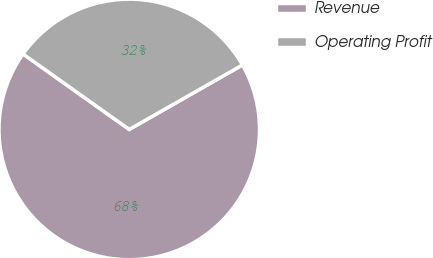Convert chart to OTSL. <chart><loc_0><loc_0><loc_500><loc_500><pie_chart><fcel>Revenue<fcel>Operating Profit<nl><fcel>68.07%<fcel>31.93%<nl></chart> 